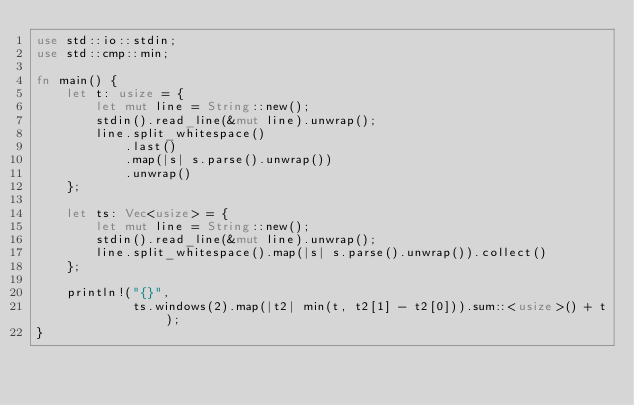Convert code to text. <code><loc_0><loc_0><loc_500><loc_500><_Rust_>use std::io::stdin;
use std::cmp::min;

fn main() {
    let t: usize = {
        let mut line = String::new();
        stdin().read_line(&mut line).unwrap();
        line.split_whitespace()
            .last()
            .map(|s| s.parse().unwrap())
            .unwrap()
    };

    let ts: Vec<usize> = {
        let mut line = String::new();
        stdin().read_line(&mut line).unwrap();
        line.split_whitespace().map(|s| s.parse().unwrap()).collect()
    };

    println!("{}",
             ts.windows(2).map(|t2| min(t, t2[1] - t2[0])).sum::<usize>() + t);
}
</code> 